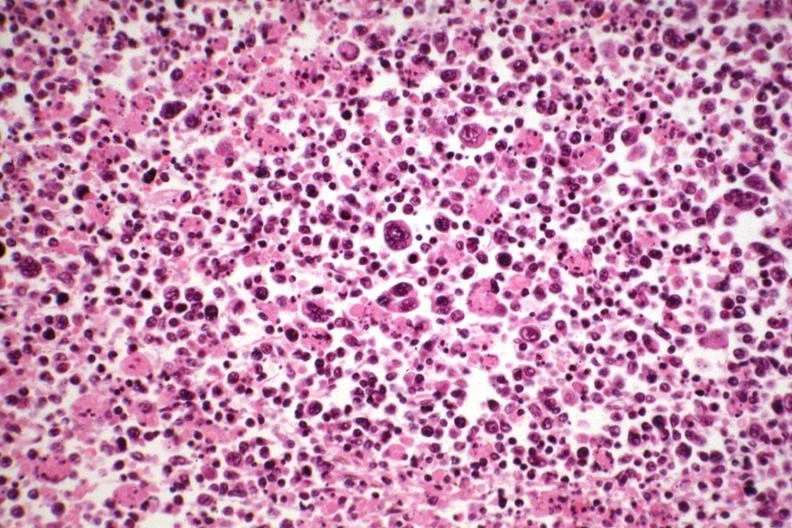does hodgkins see other slides in file?
Answer the question using a single word or phrase. Yes 